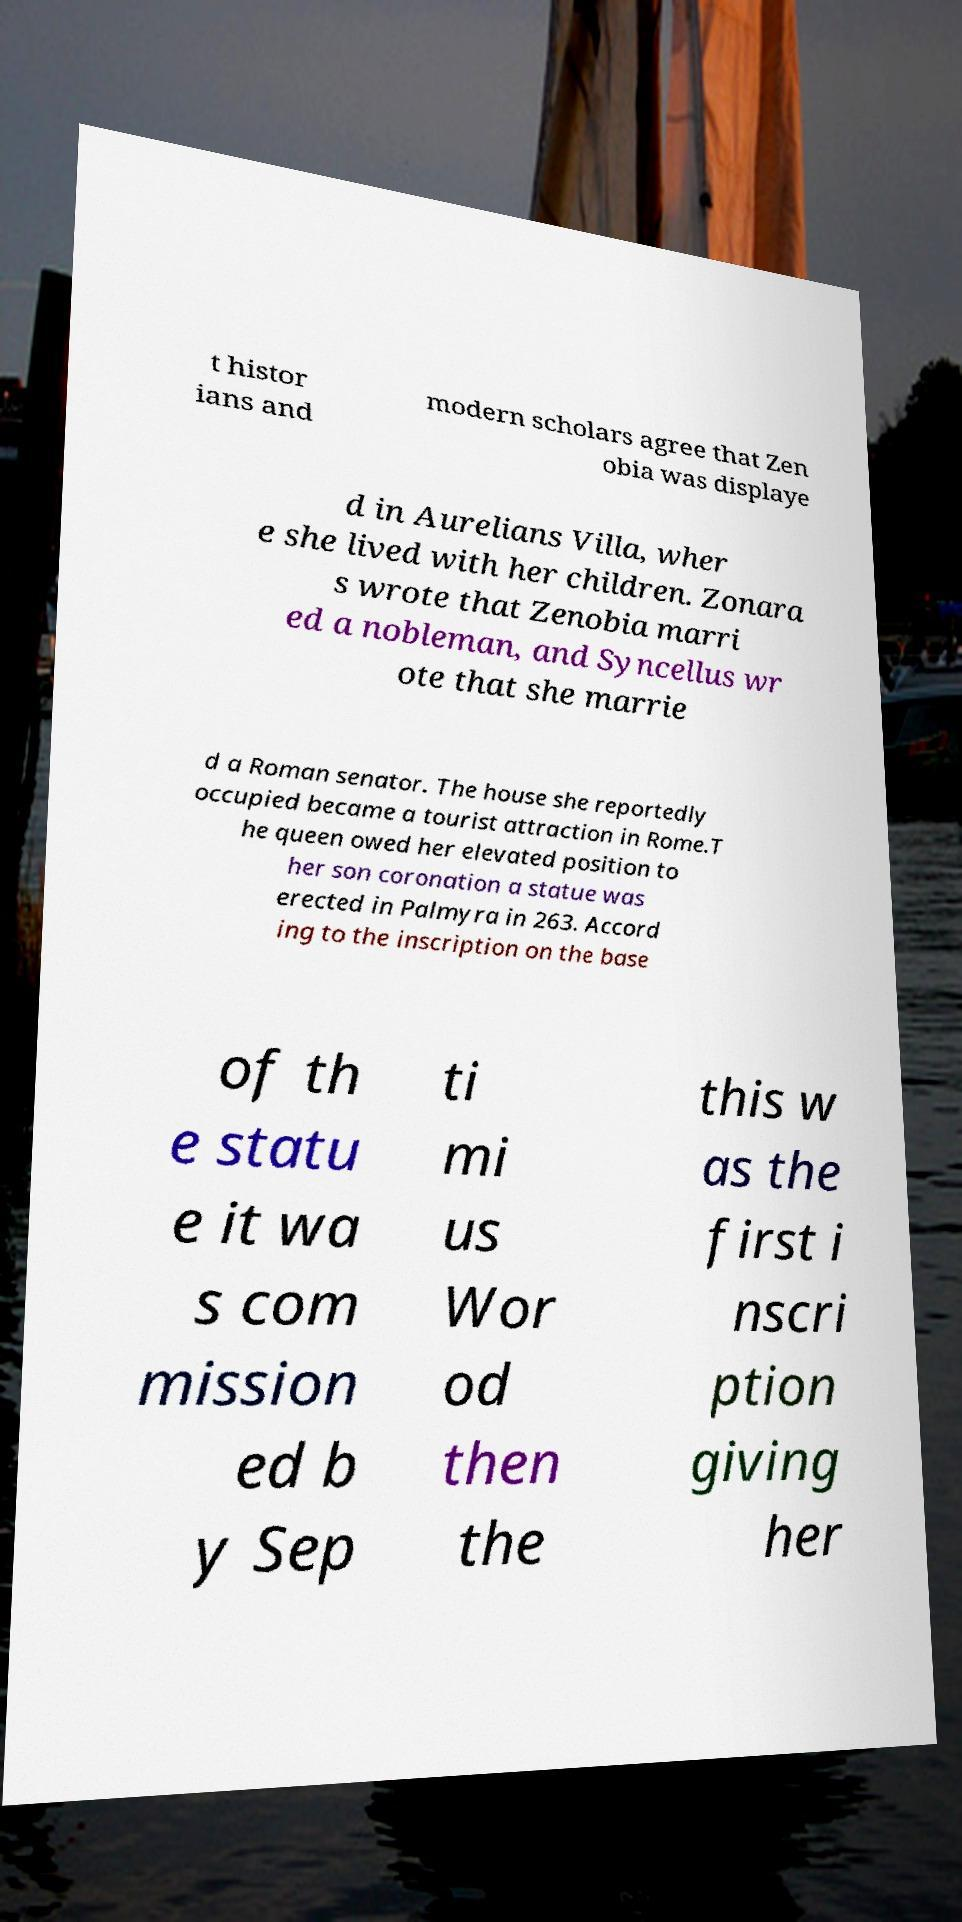Could you assist in decoding the text presented in this image and type it out clearly? t histor ians and modern scholars agree that Zen obia was displaye d in Aurelians Villa, wher e she lived with her children. Zonara s wrote that Zenobia marri ed a nobleman, and Syncellus wr ote that she marrie d a Roman senator. The house she reportedly occupied became a tourist attraction in Rome.T he queen owed her elevated position to her son coronation a statue was erected in Palmyra in 263. Accord ing to the inscription on the base of th e statu e it wa s com mission ed b y Sep ti mi us Wor od then the this w as the first i nscri ption giving her 